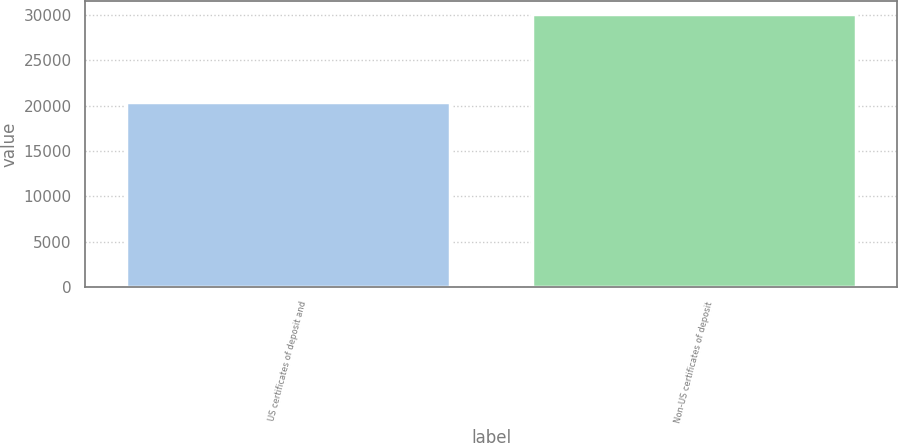<chart> <loc_0><loc_0><loc_500><loc_500><bar_chart><fcel>US certificates of deposit and<fcel>Non-US certificates of deposit<nl><fcel>20402<fcel>30060<nl></chart> 